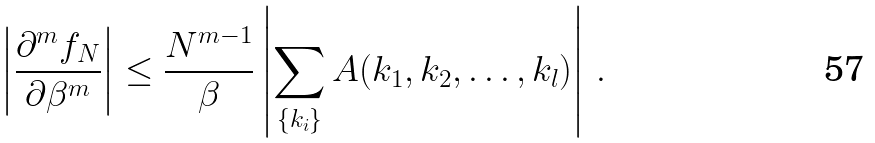<formula> <loc_0><loc_0><loc_500><loc_500>\left | \frac { \partial ^ { m } f _ { N } } { \partial \beta ^ { m } } \right | \leq \frac { N ^ { m - 1 } } { \beta } \left | \sum _ { \{ k _ { i } \} } A ( k _ { 1 } , k _ { 2 } , \dots , k _ { l } ) \right | \, .</formula> 